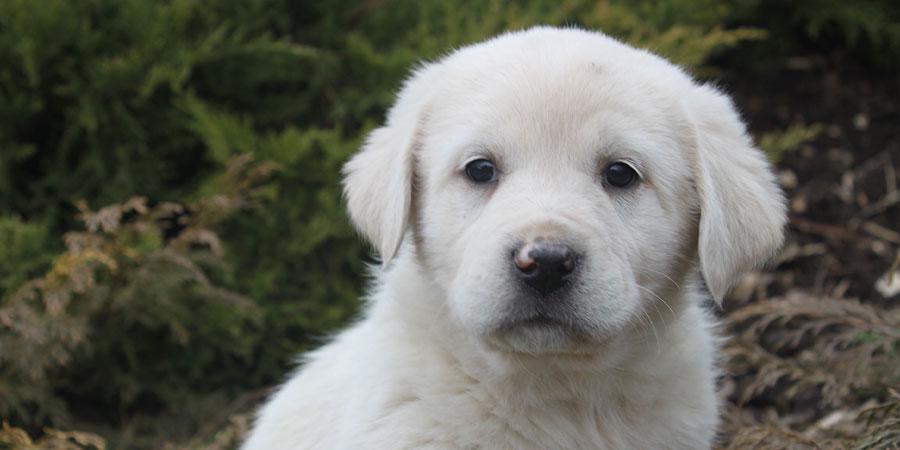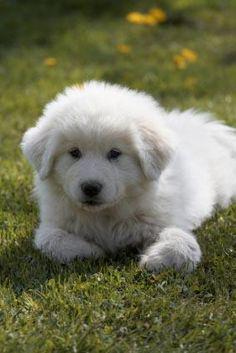The first image is the image on the left, the second image is the image on the right. Analyze the images presented: Is the assertion "a dog is laying in the grass in the left image" valid? Answer yes or no. No. The first image is the image on the left, the second image is the image on the right. Analyze the images presented: Is the assertion "A young puppy is lying down in one of the images." valid? Answer yes or no. Yes. 